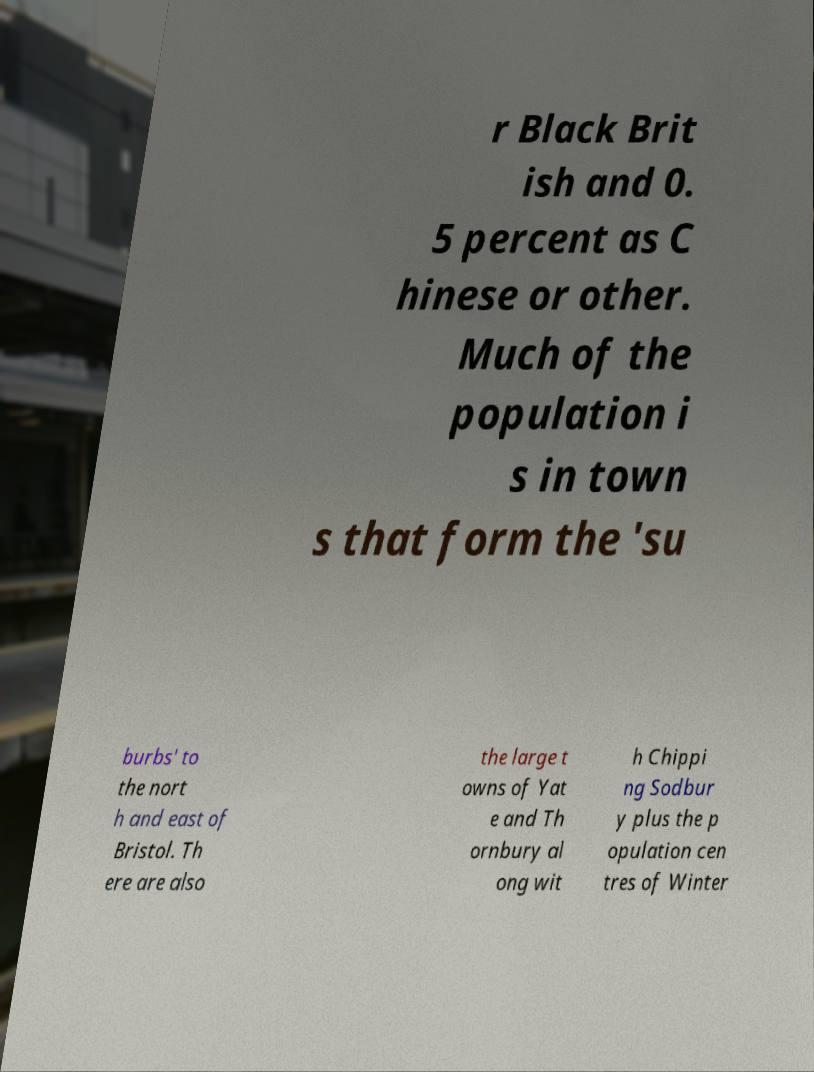Can you accurately transcribe the text from the provided image for me? r Black Brit ish and 0. 5 percent as C hinese or other. Much of the population i s in town s that form the 'su burbs' to the nort h and east of Bristol. Th ere are also the large t owns of Yat e and Th ornbury al ong wit h Chippi ng Sodbur y plus the p opulation cen tres of Winter 